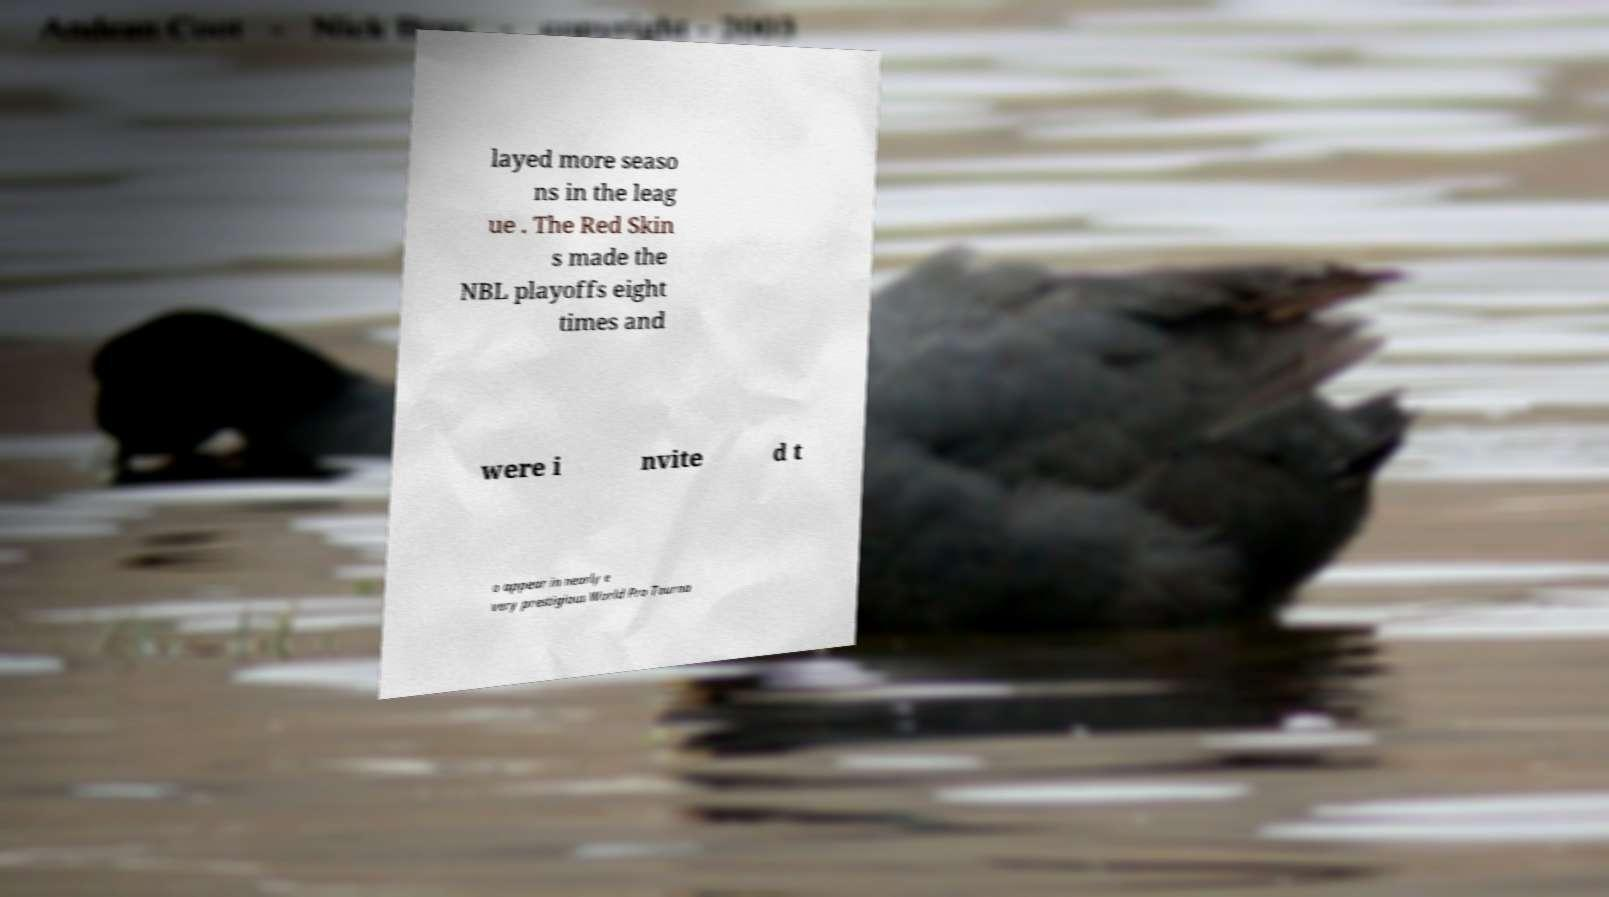For documentation purposes, I need the text within this image transcribed. Could you provide that? layed more seaso ns in the leag ue . The Red Skin s made the NBL playoffs eight times and were i nvite d t o appear in nearly e very prestigious World Pro Tourna 